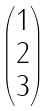<formula> <loc_0><loc_0><loc_500><loc_500>\begin{pmatrix} 1 \\ 2 \\ 3 \end{pmatrix}</formula> 